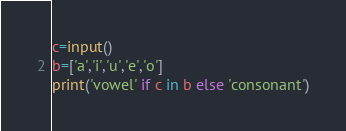<code> <loc_0><loc_0><loc_500><loc_500><_Python_>c=input()
b=['a','i','u','e','o']
print('vowel' if c in b else 'consonant')</code> 